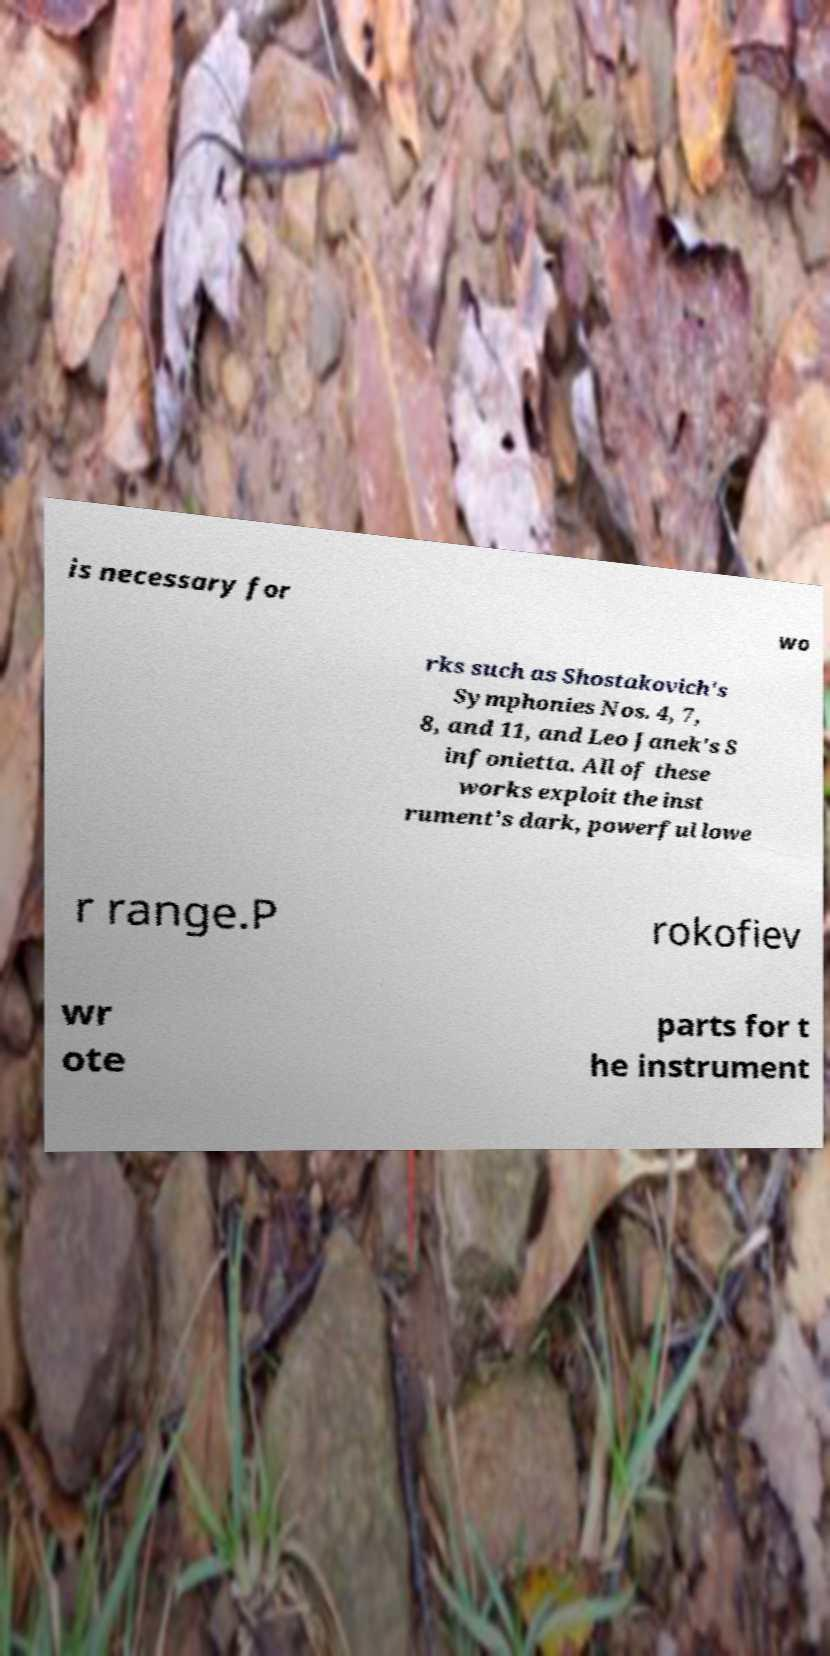Please identify and transcribe the text found in this image. is necessary for wo rks such as Shostakovich's Symphonies Nos. 4, 7, 8, and 11, and Leo Janek's S infonietta. All of these works exploit the inst rument's dark, powerful lowe r range.P rokofiev wr ote parts for t he instrument 